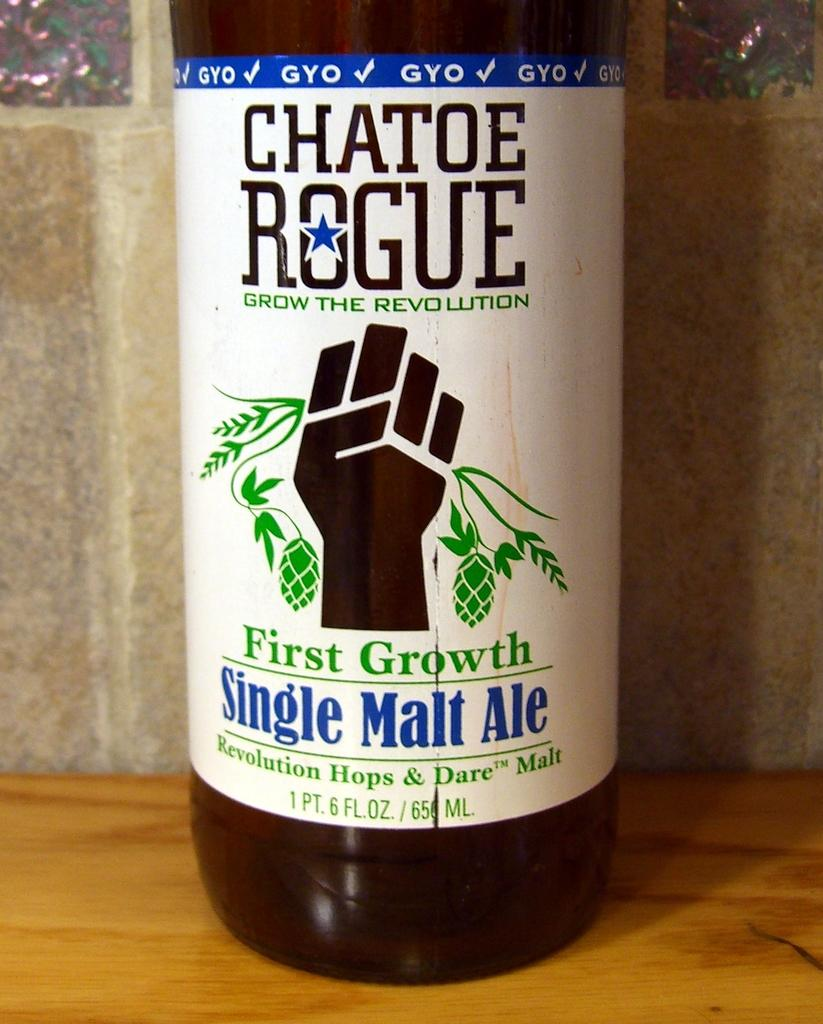<image>
Relay a brief, clear account of the picture shown. A full bottle of Chatoe Rogue Single Malt Ale. 